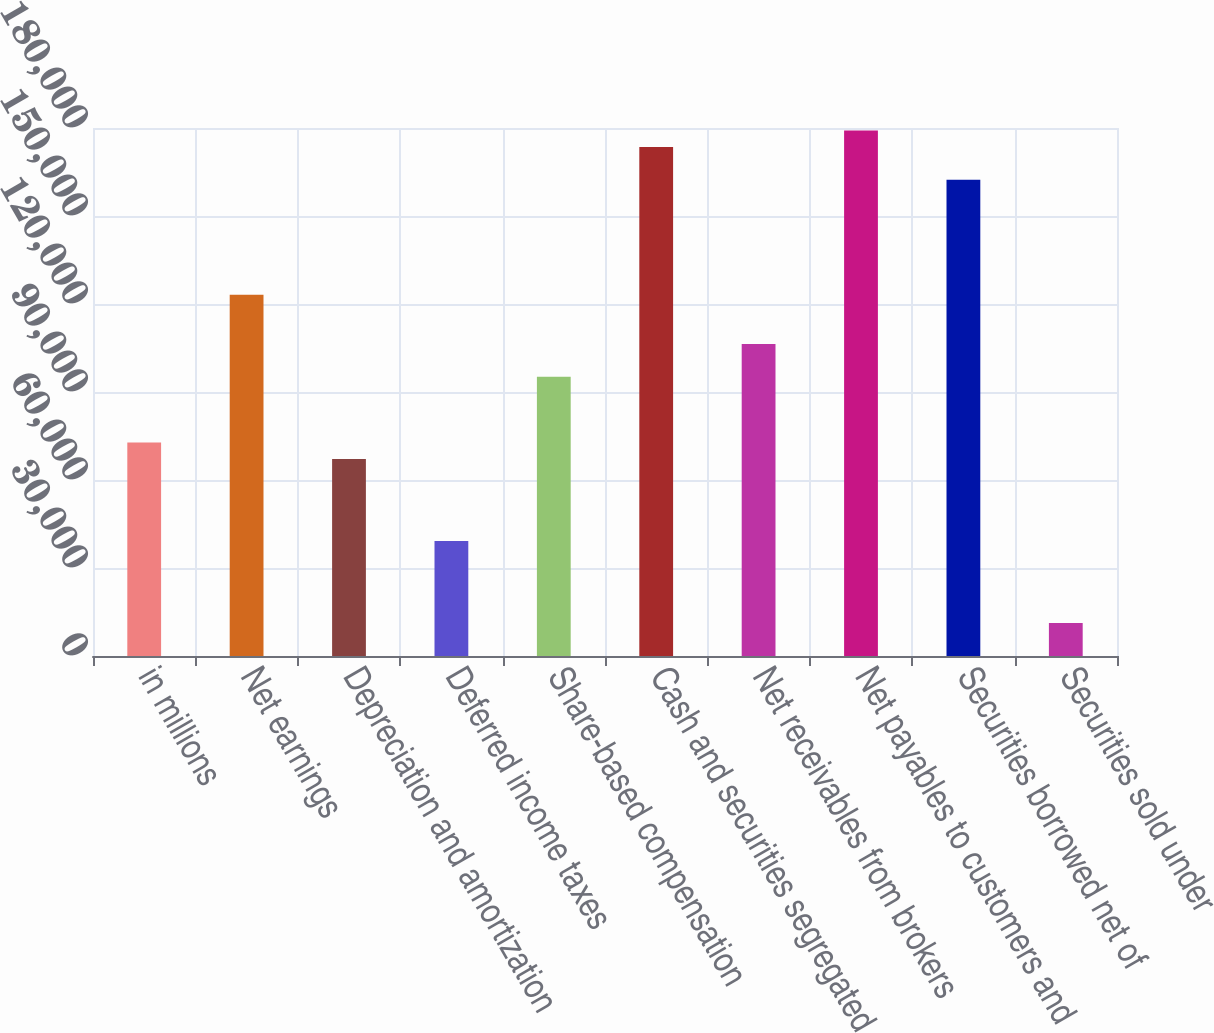Convert chart. <chart><loc_0><loc_0><loc_500><loc_500><bar_chart><fcel>in millions<fcel>Net earnings<fcel>Depreciation and amortization<fcel>Deferred income taxes<fcel>Share-based compensation<fcel>Cash and securities segregated<fcel>Net receivables from brokers<fcel>Net payables to customers and<fcel>Securities borrowed net of<fcel>Securities sold under<nl><fcel>72798.4<fcel>123170<fcel>67201.6<fcel>39217.6<fcel>95185.6<fcel>173541<fcel>106379<fcel>179138<fcel>162347<fcel>11233.6<nl></chart> 